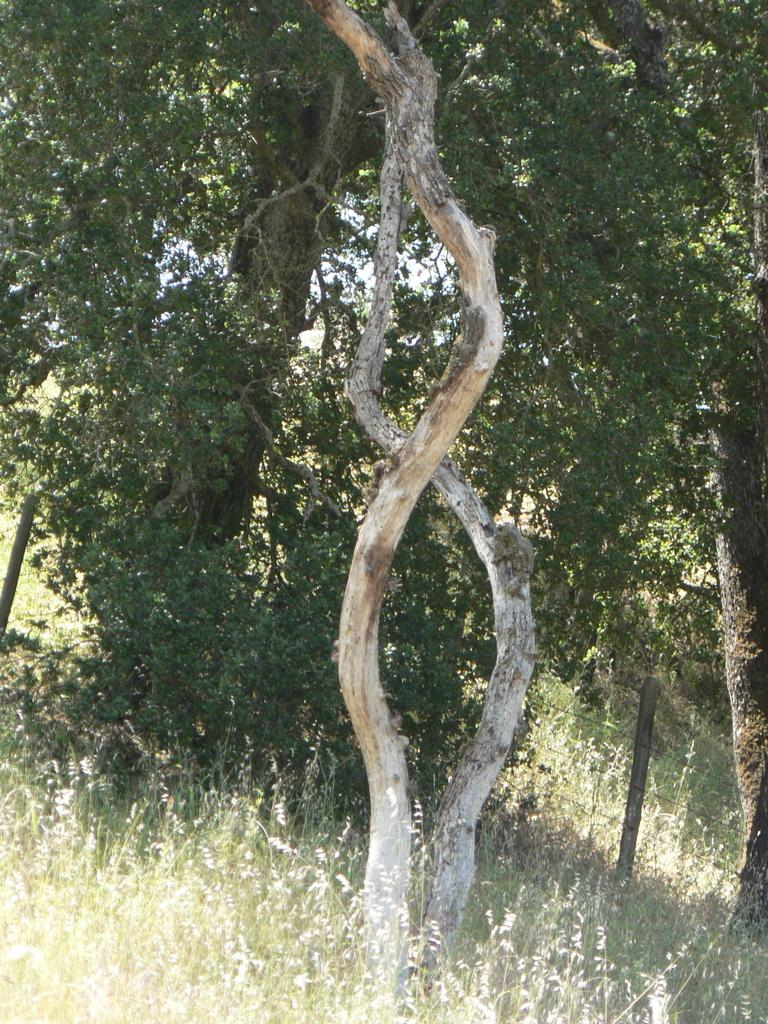What is the main subject in the center of the image? There is a fencing in the center of the image. What can be seen in the background of the image? Trees are present in the background of the image. What type of vegetation is visible at the top of the image? Grass is visible at the top of the image. What is present at the bottom of the image? The sky is present at the bottom of the image. How many toothpaste tubes are visible in the image? There are no toothpaste tubes present in the image. What color is the balloon floating in the sky at the bottom of the image? There is no balloon present in the image; the bottom of the image features the sky. 